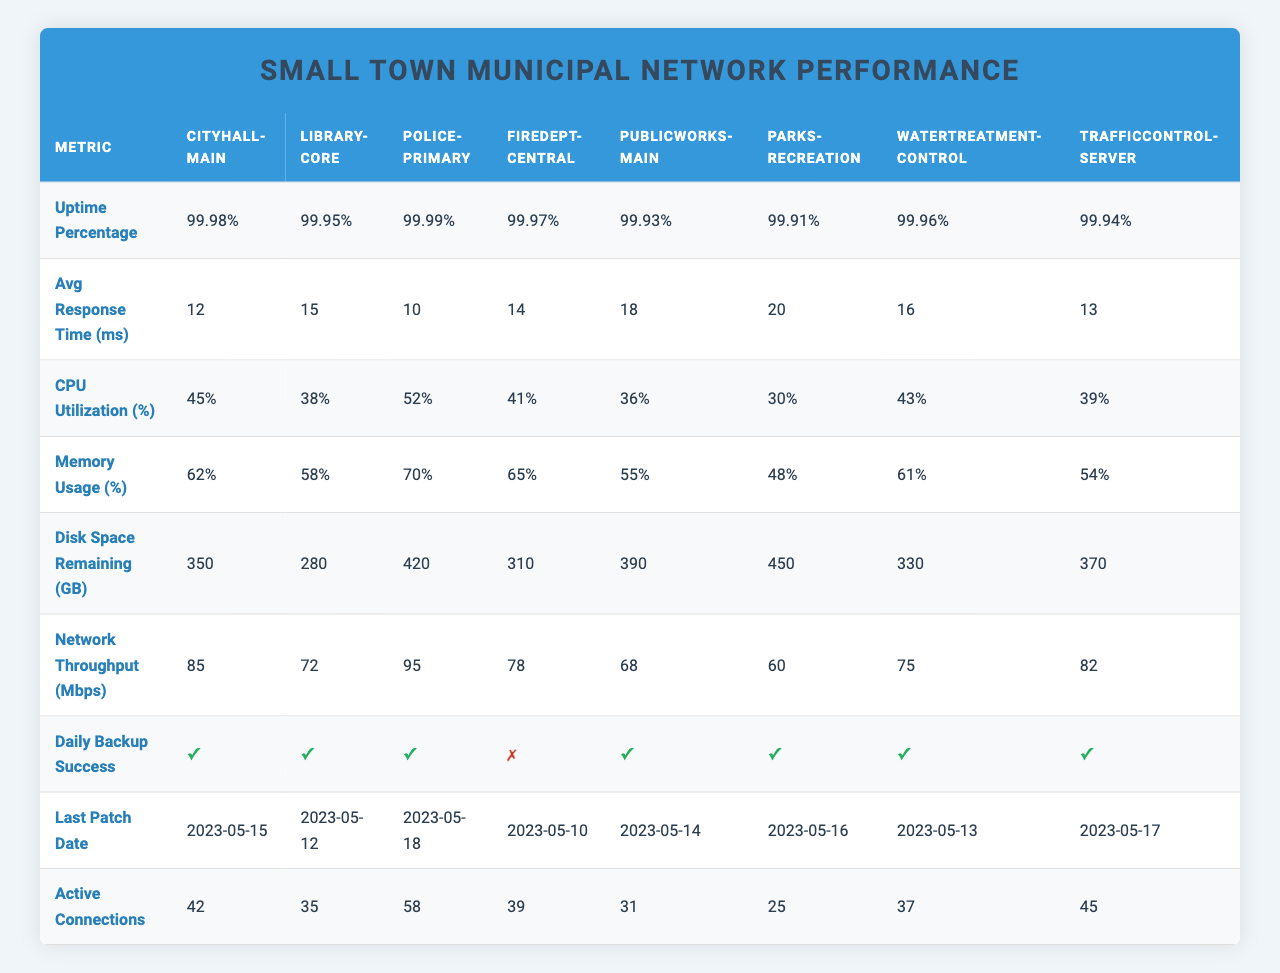What is the uptime percentage of the Police-Primary server? The uptime percentage for the Police-Primary server is listed directly in the table under "Uptime Percentage", which indicates it is 99.99%.
Answer: 99.99% Which server has the highest CPU utilization? To find this, we look at the "CPU Utilization" row in the table and compare the values. The Police-Primary server has the highest at 52%.
Answer: Police-Primary What is the average response time across all servers? First, we need to add all the average response times: (12 + 15 + 10 + 14 + 18 + 20 + 16 + 13) = 118. There are 8 servers, so we divide 118 by 8 to get the average, which is 14.75 milliseconds.
Answer: 14.75 ms Is the daily backup successful for the FireDept-Central server? Looking under the "Daily Backup Success" row, the FireDept-Central server shows a "✗", meaning the backup was not successful.
Answer: No How much disk space remains for the Library-Core server? The "Disk Space Remaining" row shows that the Library-Core server has 280 GB remaining, which we can find by directly referring to this entry in the table.
Answer: 280 GB What is the memory usage percentage for the server with the lowest average response time? First, we identify the server with the lowest average response time, which is the Police-Primary server at 10 ms. Looking at the "Memory Usage" row, its percentage is 70%.
Answer: 70% How many active connections does the CityHall-Main server have, and how does that compare to the average across all servers? The CityHall-Main server has 42 active connections. To find the average, we sum the active connections (42 + 35 + 58 + 39 + 31 + 25 + 37 + 45) = 312, and divide by 8, which gives us 39 active connections on average. The CityHall-Main server is above the average by 3 connections.
Answer: 42 connections, above average by 3 Are there any servers that have a daily backup failure? By reviewing the "Daily Backup Success" row, we see that the FireDept-Central server is the only one marked with a "✗", indicating that it did not have a successful backup.
Answer: Yes, FireDept-Central What is the difference in network throughput between the Parks-Recreation server and the WaterTreatment-Control server? The Parks-Recreation server has a network throughput of 60 Mbps, and the WaterTreatment-Control server has 75 Mbps. The difference is 75 - 60 = 15 Mbps.
Answer: 15 Mbps Which server has the latest patch date, and what is that date? We look under the "Last Patch Date" column to find that the Police-Primary server was patched on 2023-05-18, which is the latest date listed in the table.
Answer: Police-Primary, 2023-05-18 